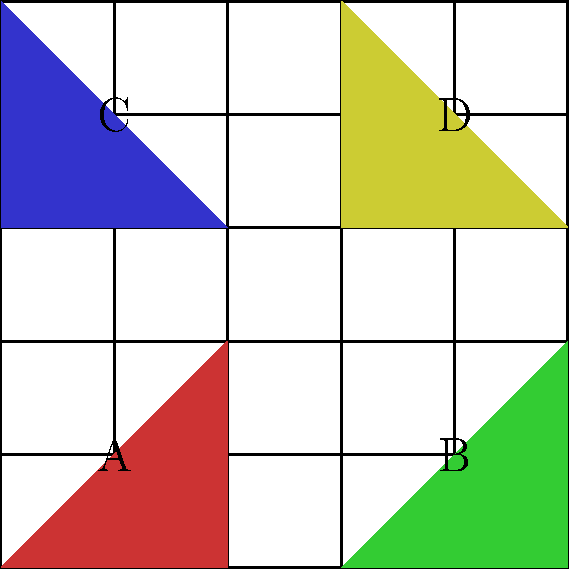In this grid-based tangram-style puzzle, you need to identify congruent shapes. How many pairs of congruent triangles are there in the given arrangement? Justify your answer using the properties of congruence and the information provided in the grid. To solve this puzzle, we need to analyze the triangles and their properties:

1. First, let's identify the triangles:
   - Triangle A: Bottom-left (red)
   - Triangle B: Bottom-right (green)
   - Triangle C: Top-left (blue)
   - Triangle D: Top-right (yellow)

2. To determine congruence, we need to check if the triangles have the same shape and size. We can do this by comparing their side lengths and angles.

3. Let's analyze each triangle:
   - Triangle A: Base = 2 units, Height = 2 units
   - Triangle B: Base = 2 units, Height = 2 units
   - Triangle C: Base = 2 units, Height = 2 units
   - Triangle D: Base = 2 units, Height = 2 units

4. All four triangles have a base of 2 units and a height of 2 units. This means they are all right-angled isosceles triangles.

5. In a 5x5 grid, we can confirm that all these triangles have the same dimensions:
   - Leg 1 = 2 units
   - Leg 2 = 2 units
   - Hypotenuse = $\sqrt{2^2 + 2^2} = 2\sqrt{2}$ units

6. Since all four triangles have the same side lengths and angles, they are all congruent to each other.

7. To count the number of congruent pairs, we use the combination formula:
   $$\binom{4}{2} = \frac{4!}{2!(4-2)!} = \frac{4 \cdot 3}{2 \cdot 1} = 6$$

Therefore, there are 6 pairs of congruent triangles in this arrangement.
Answer: 6 pairs 